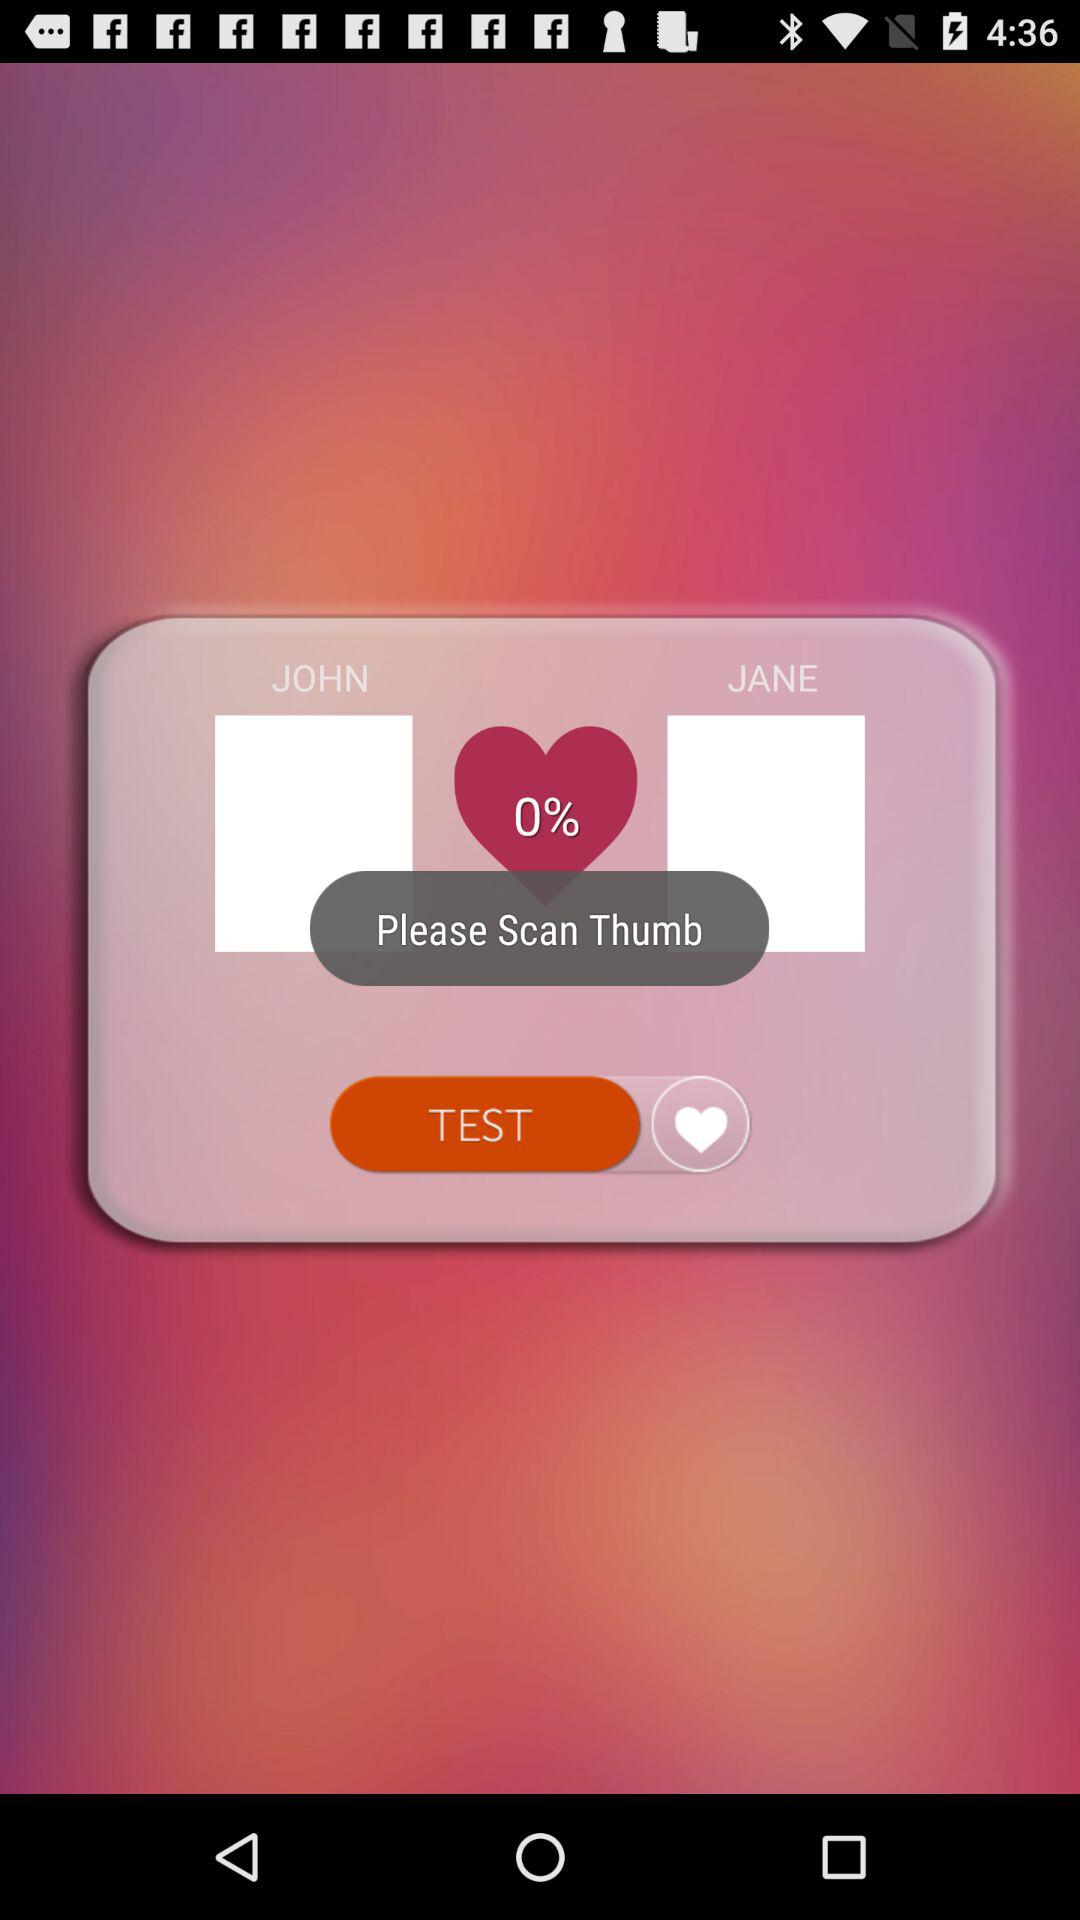What are the names of the matched people? The names of the matched people are John and Jane. 